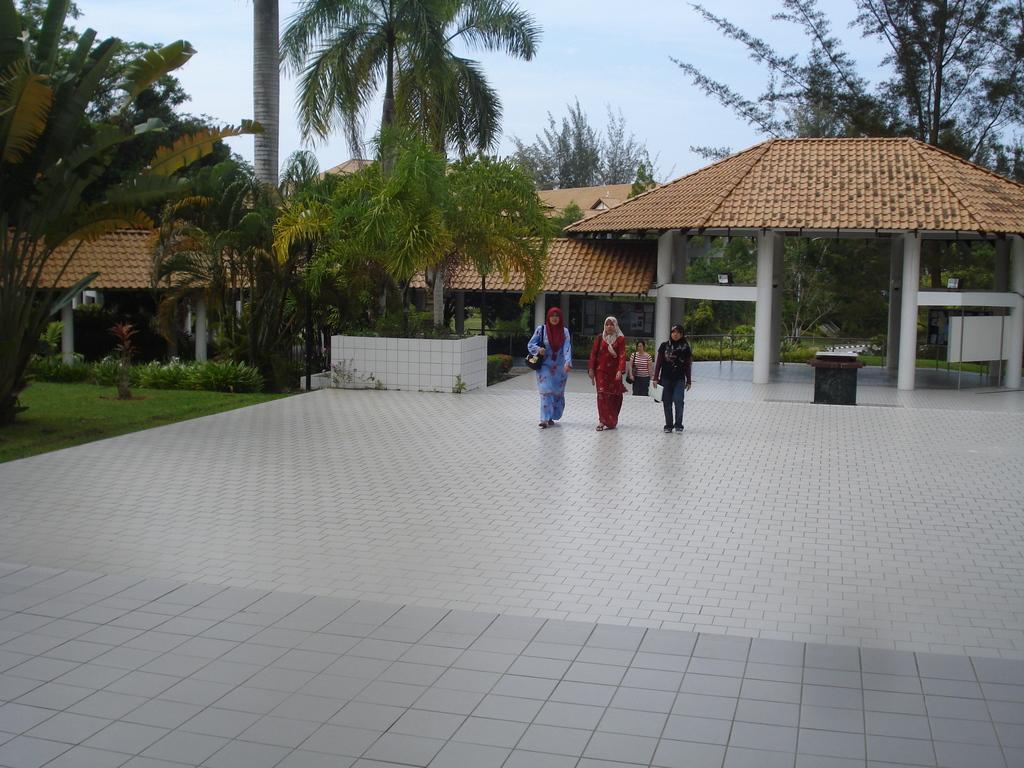Describe this image in one or two sentences. In this image we can see a few people, some of them are wearing bags, there are plants, trees, houses, also we can see the sky. 